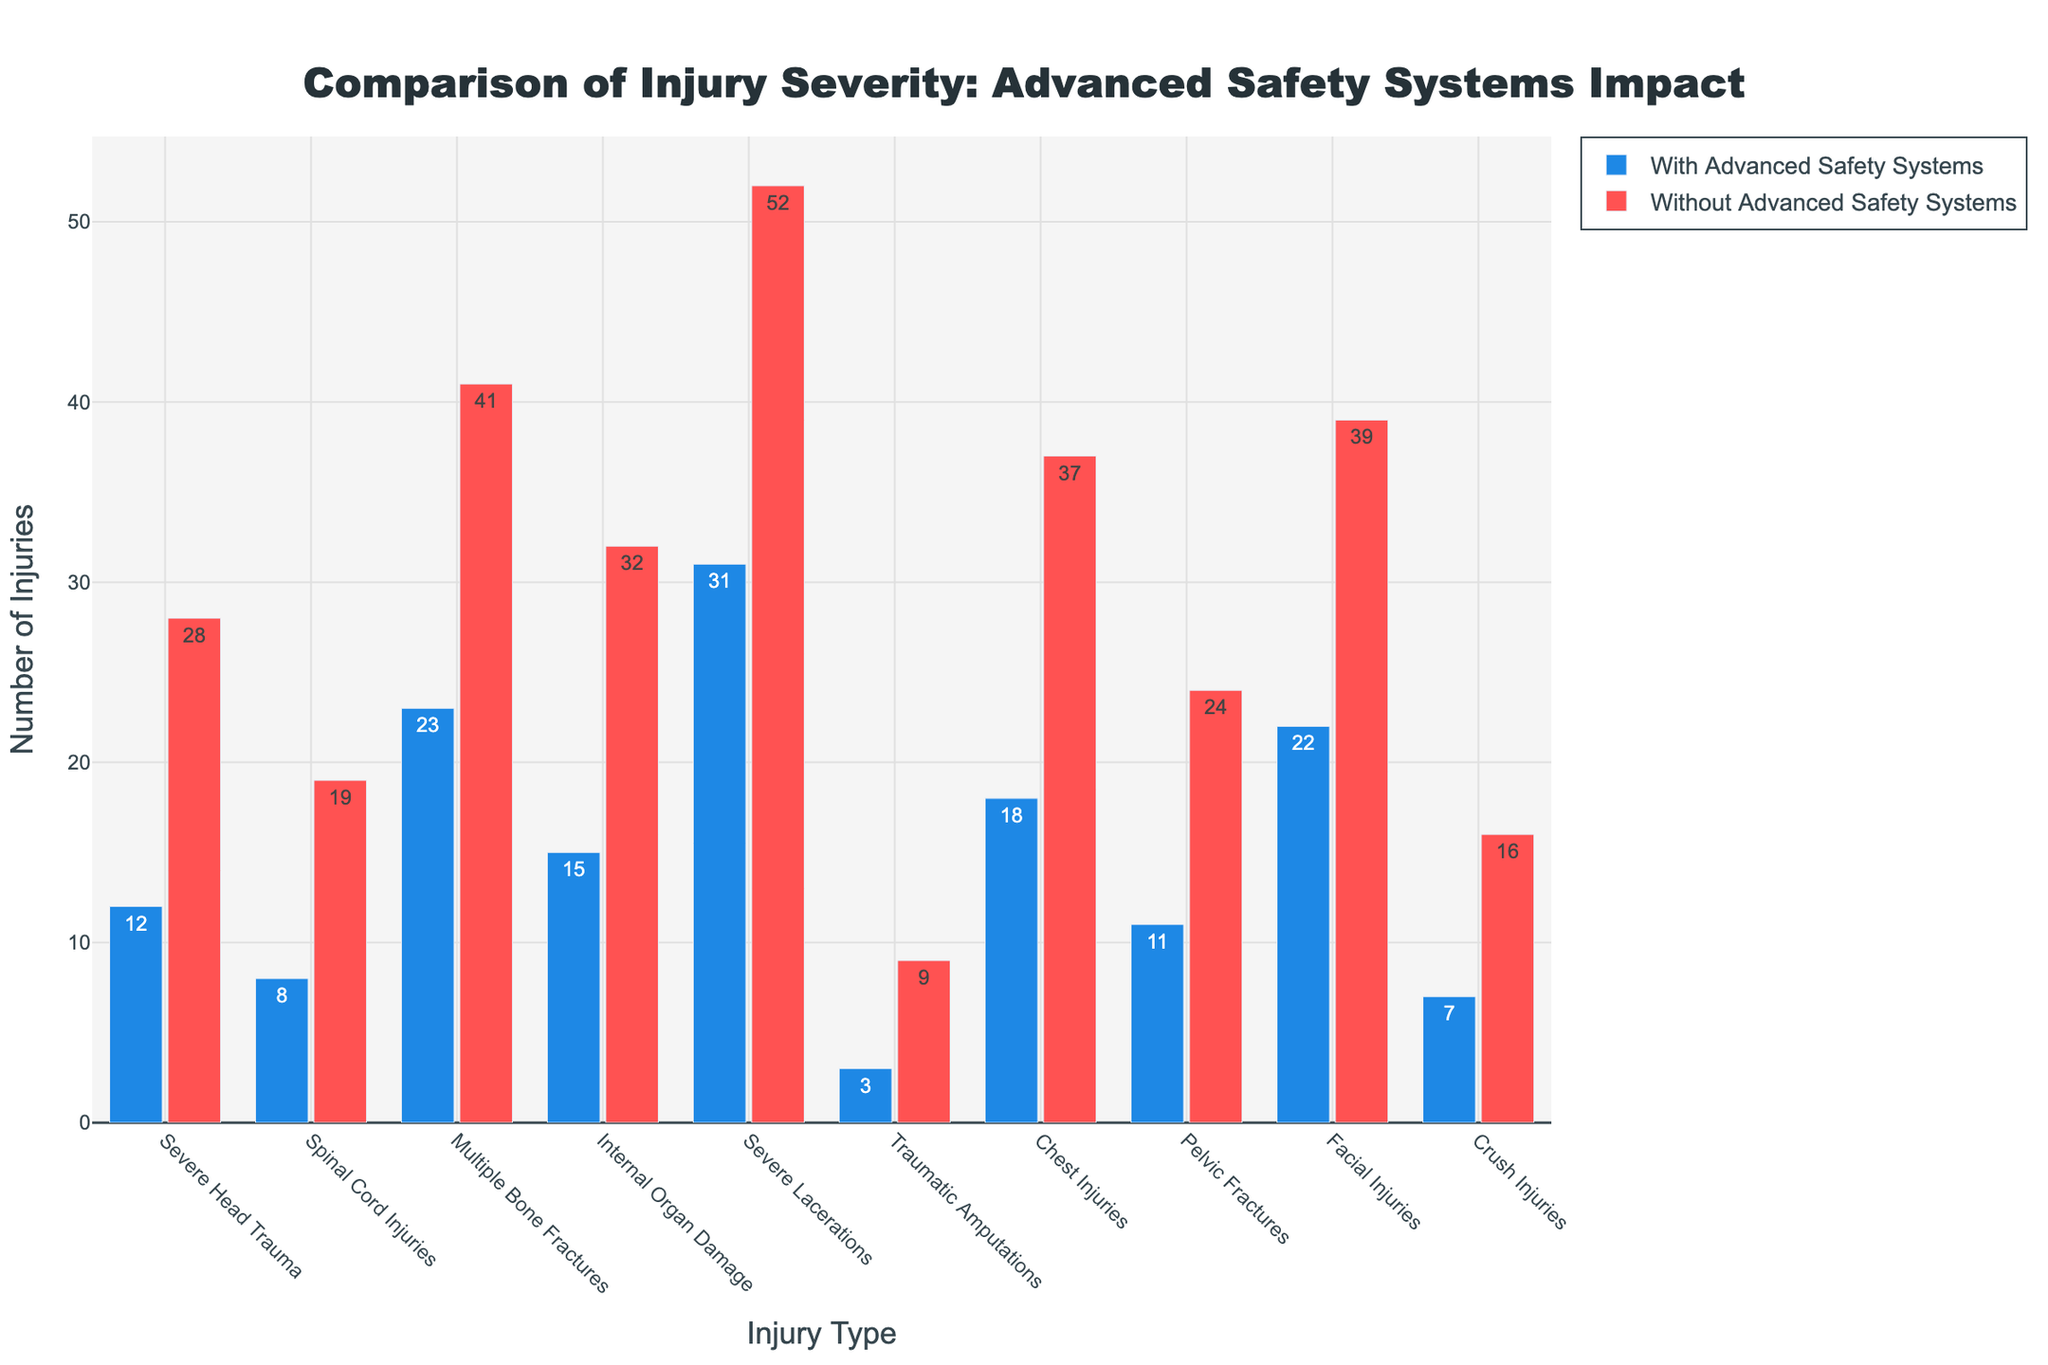Which injury type has the highest number of occurrences in vehicles without advanced safety systems? Look at the red bars for each injury type and identify the one with the highest value. Severe Lacerations at 52 is the highest.
Answer: Severe Lacerations What is the difference in the number of severe head trauma cases between vehicles with and without advanced safety systems? Subtract the number of severe head trauma cases with advanced safety systems (12) from without advanced safety systems (28). 28 - 12 = 16
Answer: 16 Which injury type shows the smallest difference between vehicles with and without advanced safety systems? Calculate the differences for each injury type and find the smallest one. Traumatic Amputations have the smallest difference: 9 - 3 = 6.
Answer: Traumatic Amputations How many more cases of multiple bone fractures occur in vehicles without advanced safety systems compared to those with advanced safety systems? Subtract the number of multiple bone fractures with advanced safety systems (23) from without advanced safety systems (41). 41 - 23 = 18
Answer: 18 What is the total number of spinal cord injuries in both vehicle types? Add the number of spinal cord injuries with advanced safety systems (8) and without advanced safety systems (19). 8 + 19 = 27
Answer: 27 What color represents the bars for vehicles with advanced safety systems? Look at the color legend or the bars labeled with advanced safety systems. The bars are blue.
Answer: Blue For which injury type is the reduction in the number of injuries the greatest when advanced safety systems are present? Find the injury type with the highest difference when subtracting values with advanced safety systems from without advanced safety systems. Severe Lacerations: 52 - 31 = 21
Answer: Severe Lacerations Are there more cases of chest injuries or pelvic fractures in vehicles without advanced safety systems? Compare the height of the red bars for chest injuries (37) and pelvic fractures (24). There are more cases of chest injuries.
Answer: Chest Injuries What is the average number of facial injuries in both vehicle types? Add the number of facial injuries with advanced safety systems (22) and without advanced safety systems (39). Then divide by 2. (22 + 39) / 2 = 30.5
Answer: 30.5 Which injury type has the closest number of cases in vehicles with advanced safety systems to chest injuries in vehicles without advanced safety systems? Compare the blue bars and find which values are close to 37 (chest injuries without advanced safety systems). Chest injuries with advanced safety systems is closest with 18.
Answer: Chest Injuries 